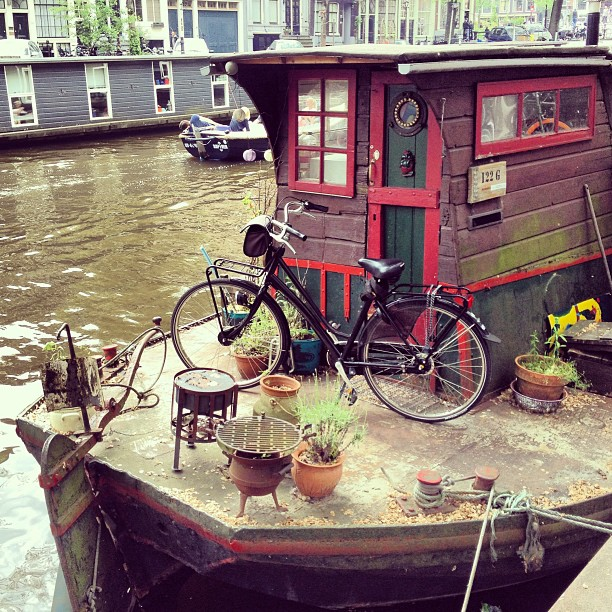Please provide the bounding box coordinate of the region this sentence describes: a small black boat in the water. The coordinates for the small black boat in the water are approximately [0.28, 0.18, 0.43, 0.26], effectively capturing the boat within the serene water setting, slightly blending with the reflections. 